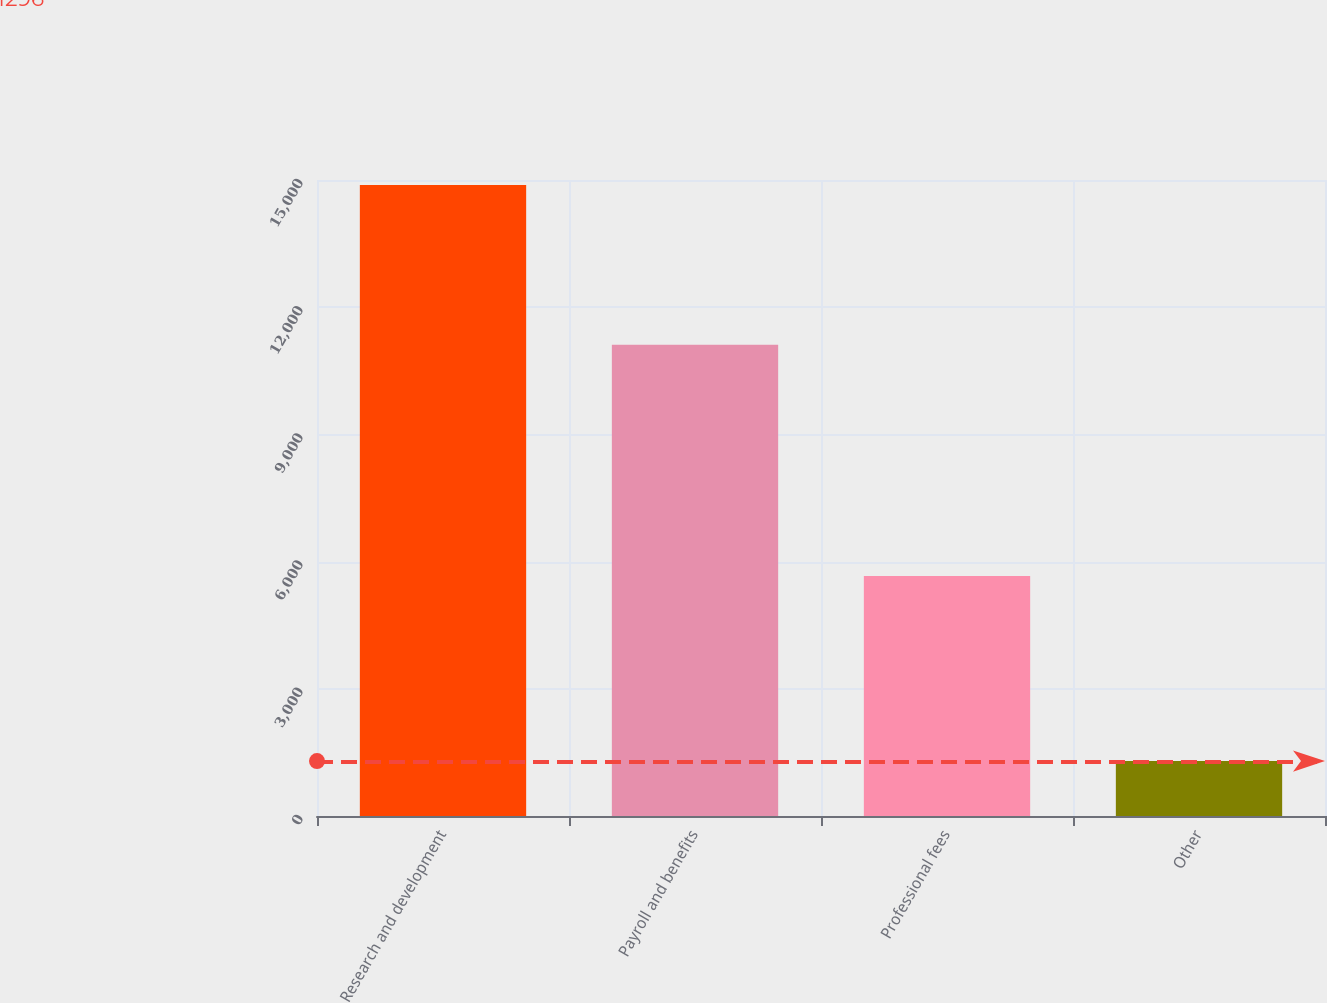Convert chart. <chart><loc_0><loc_0><loc_500><loc_500><bar_chart><fcel>Research and development<fcel>Payroll and benefits<fcel>Professional fees<fcel>Other<nl><fcel>14883<fcel>11114<fcel>5658<fcel>1296<nl></chart> 